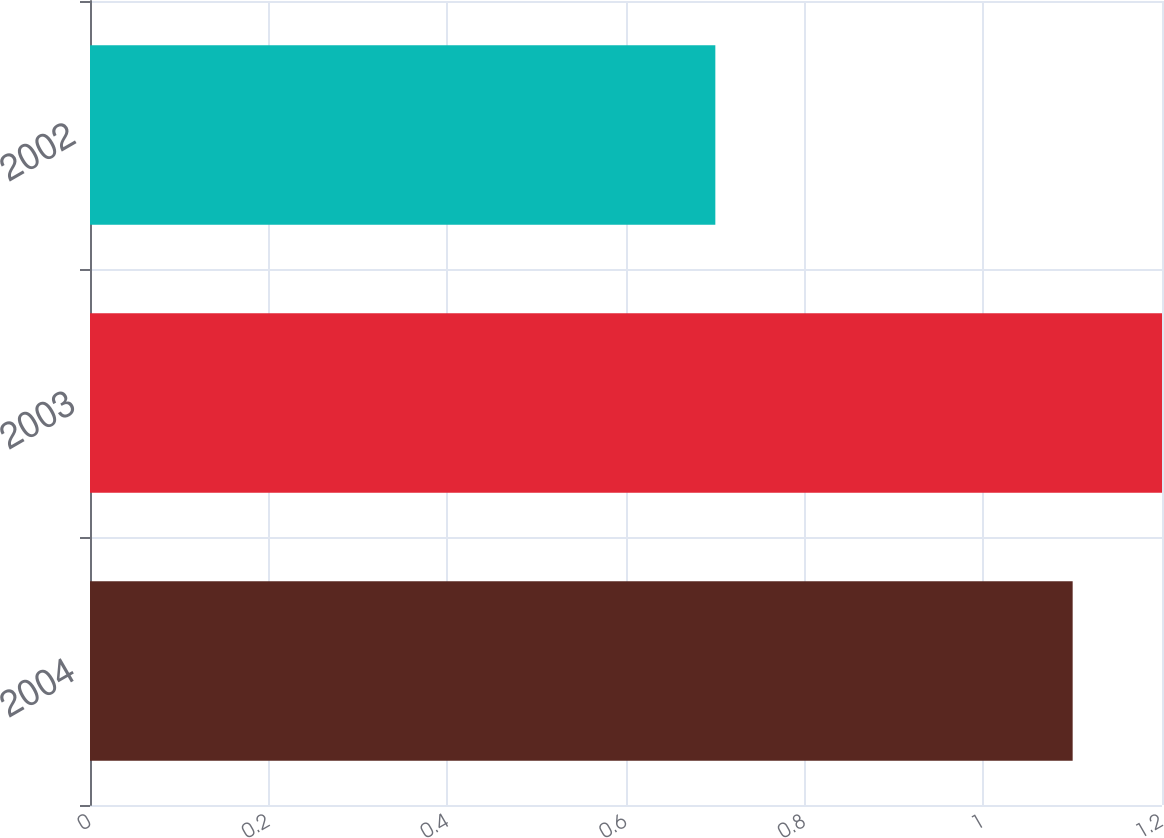<chart> <loc_0><loc_0><loc_500><loc_500><bar_chart><fcel>2004<fcel>2003<fcel>2002<nl><fcel>1.1<fcel>1.2<fcel>0.7<nl></chart> 